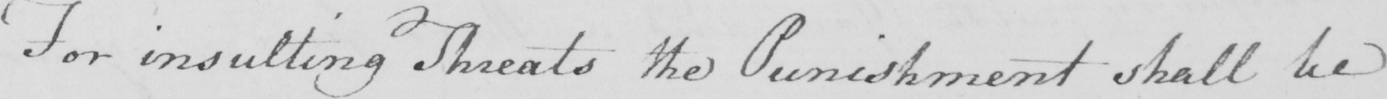What text is written in this handwritten line? For insulting Threats the Punishment shall be 